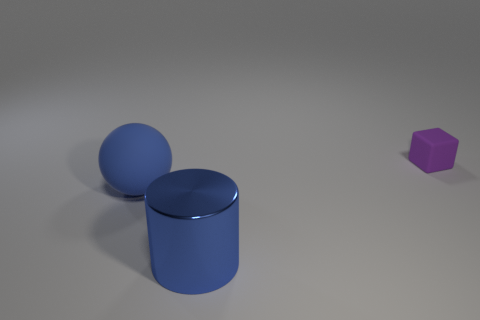Can you tell me what shapes are visible in this image? Sure, there are three distinct shapes: a blue sphere, a blue cylinder, and a small purple hexagonal prism.  What could be the possible use of these shapes? These shapes might be used for a variety of purposes, such as graphical assets in a 3D modeling software, components in a visual educational tool for geometry, or elements in a computer game to represent items or scenery. 